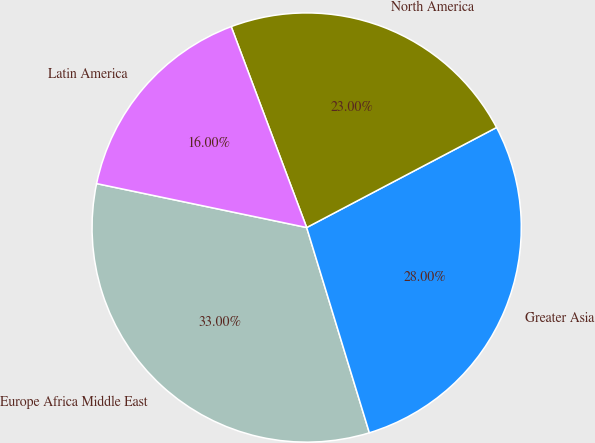Convert chart. <chart><loc_0><loc_0><loc_500><loc_500><pie_chart><fcel>Europe Africa Middle East<fcel>Greater Asia<fcel>North America<fcel>Latin America<nl><fcel>33.0%<fcel>28.0%<fcel>23.0%<fcel>16.0%<nl></chart> 